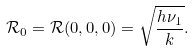Convert formula to latex. <formula><loc_0><loc_0><loc_500><loc_500>\mathcal { R } _ { 0 } = \mathcal { R } ( 0 , 0 , 0 ) = \sqrt { \frac { h \nu _ { 1 } } { k } } .</formula> 